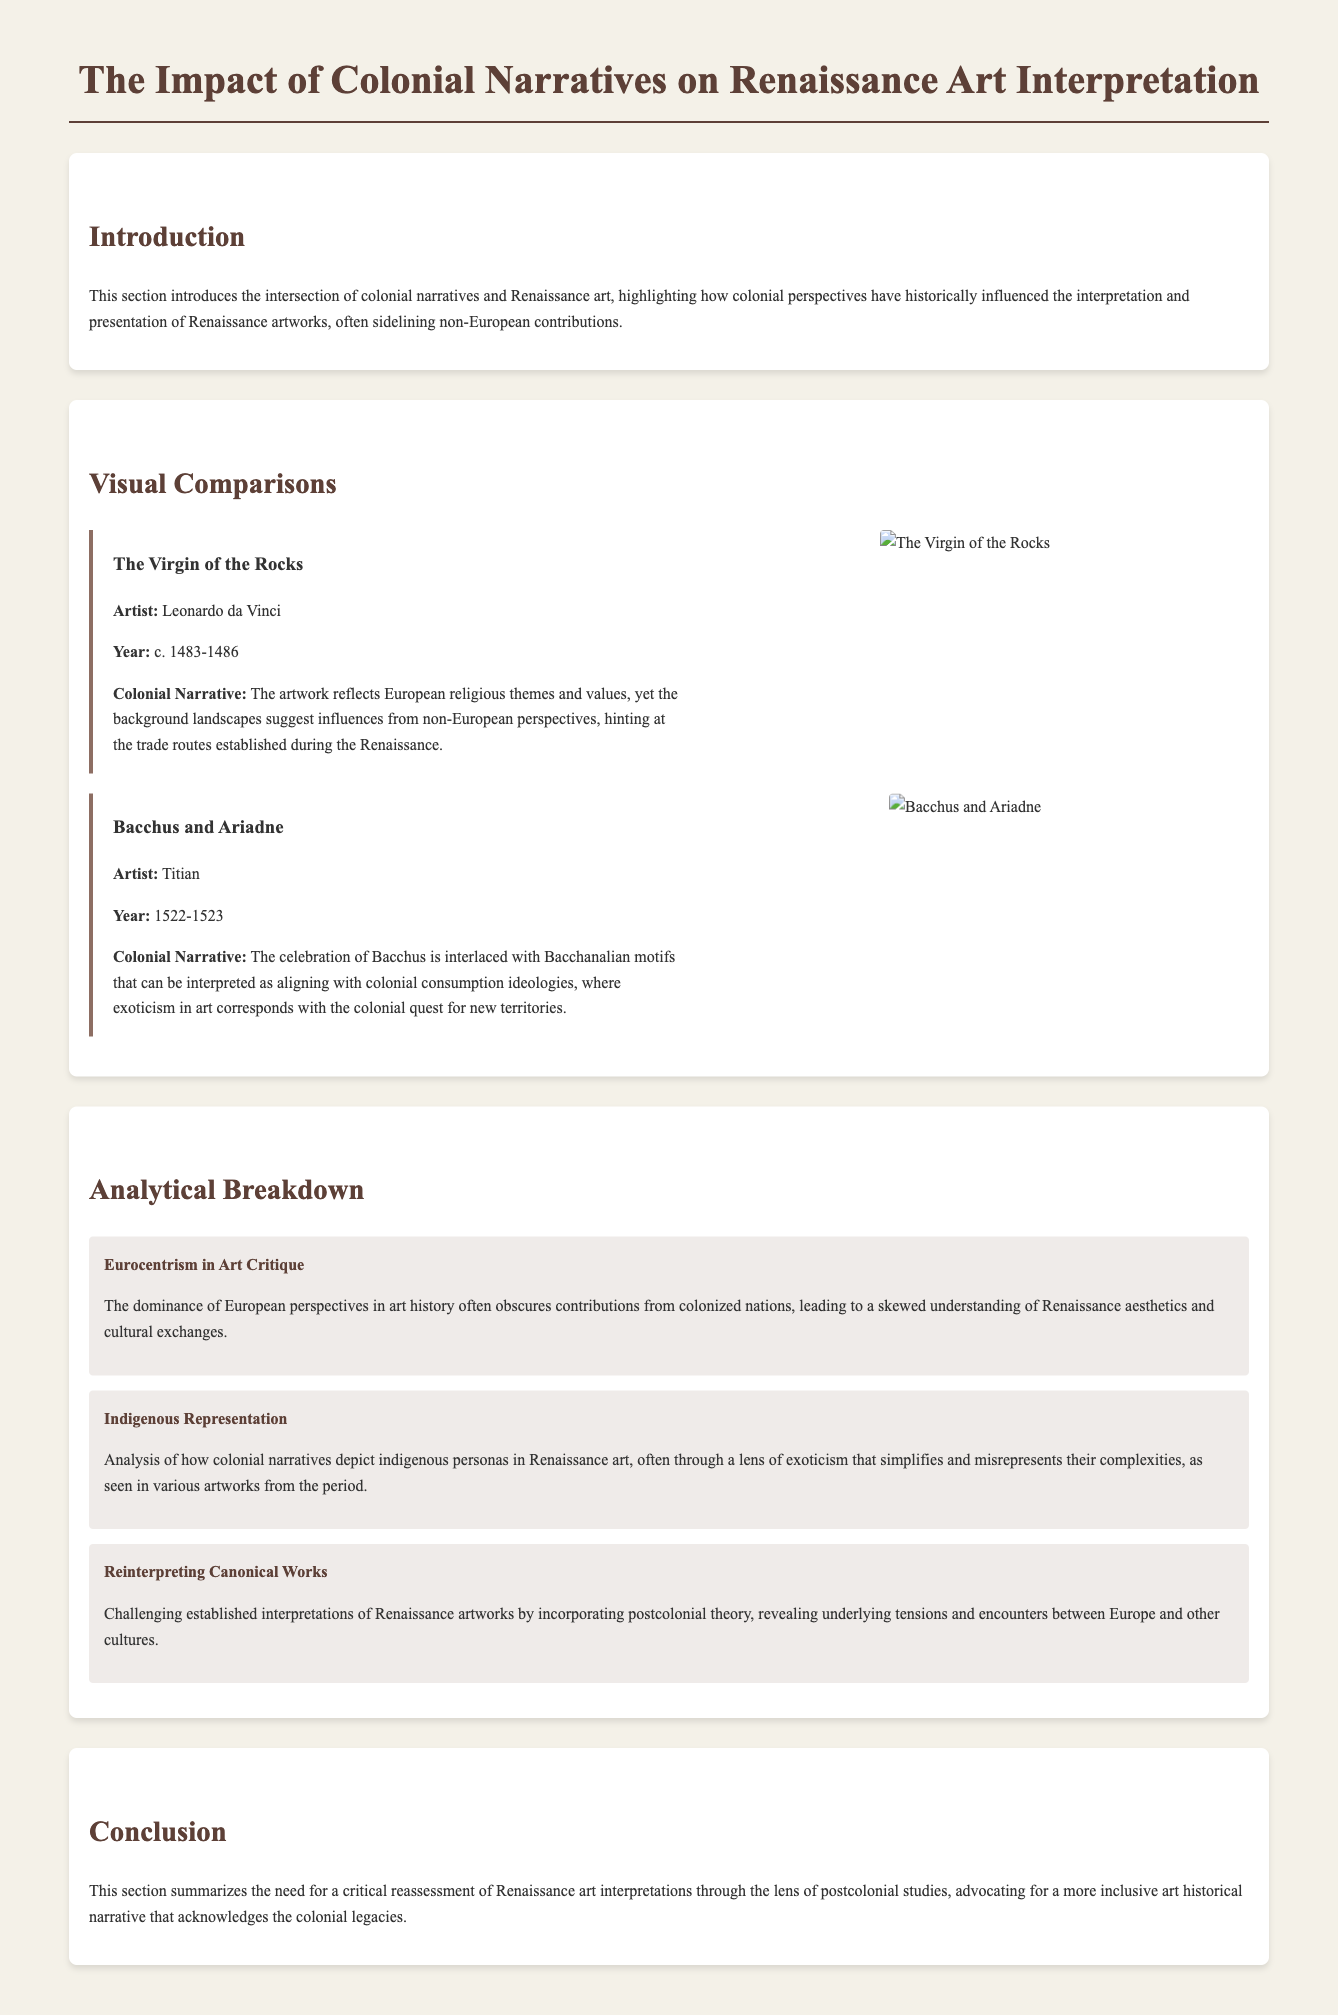What is the title of the document? The title is stated prominently at the top of the document.
Answer: The Impact of Colonial Narratives on Renaissance Art Interpretation Who is the artist of "The Virgin of the Rocks"? The artist's name is given in the visual comparison section for this artwork.
Answer: Leonardo da Vinci What year was "Bacchus and Ariadne" created? The year is specified next to the artwork title in the visual comparisons.
Answer: 1522-1523 What is one of the themes reflected in "The Virgin of the Rocks"? The document discusses specific themes associated with each artwork under the colonial narrative section.
Answer: European religious themes What does the section on Indigenous Representation analyze? This section discusses the depiction of indigenous personas in Renaissance art, according to the document.
Answer: Exoticism and misrepresentation How does the document suggest Renaissance artworks should be reinterpreted? The document proposes a method of reinterpretation in one of its analytical breakdowns.
Answer: By incorporating postcolonial theory What color is the background of the document? The background color is described in the body style of the document's CSS.
Answer: #f4f1e8 What is the purpose of the conclusion section? The conclusion summarizes the main arguments and suggestions of the document.
Answer: Critical reassessment of interpretations 